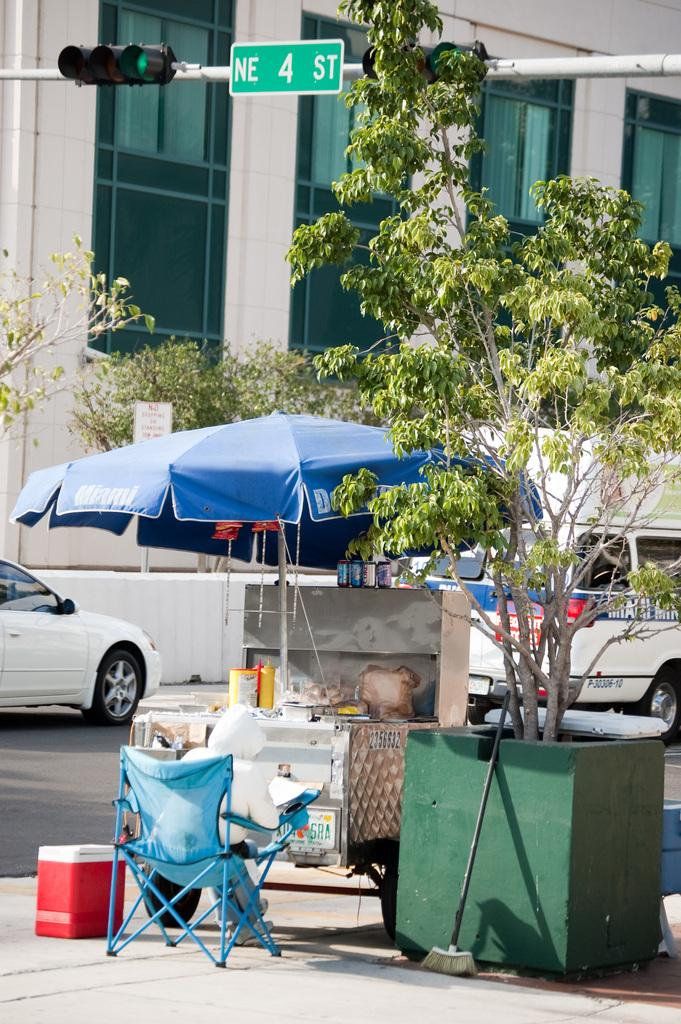What can be seen on the road in the image? There are vehicles on the road in the image. What type of temporary shelter is present in the image? There is a tent in the image. What type of furniture is present in the image? There are chairs in the image. What type of natural vegetation is present in the image? There are trees in the image. What type of objects are present in the image? There are objects in the image, but their specific nature is not mentioned. What can be seen in the background of the image? There is a building, traffic signals, and boards in the background of the image. What does the dad say about the throat in the image? There is no mention of a dad or a throat in the image. What type of street is visible in the image? There is no specific street mentioned in the image, only a road with vehicles on it. 